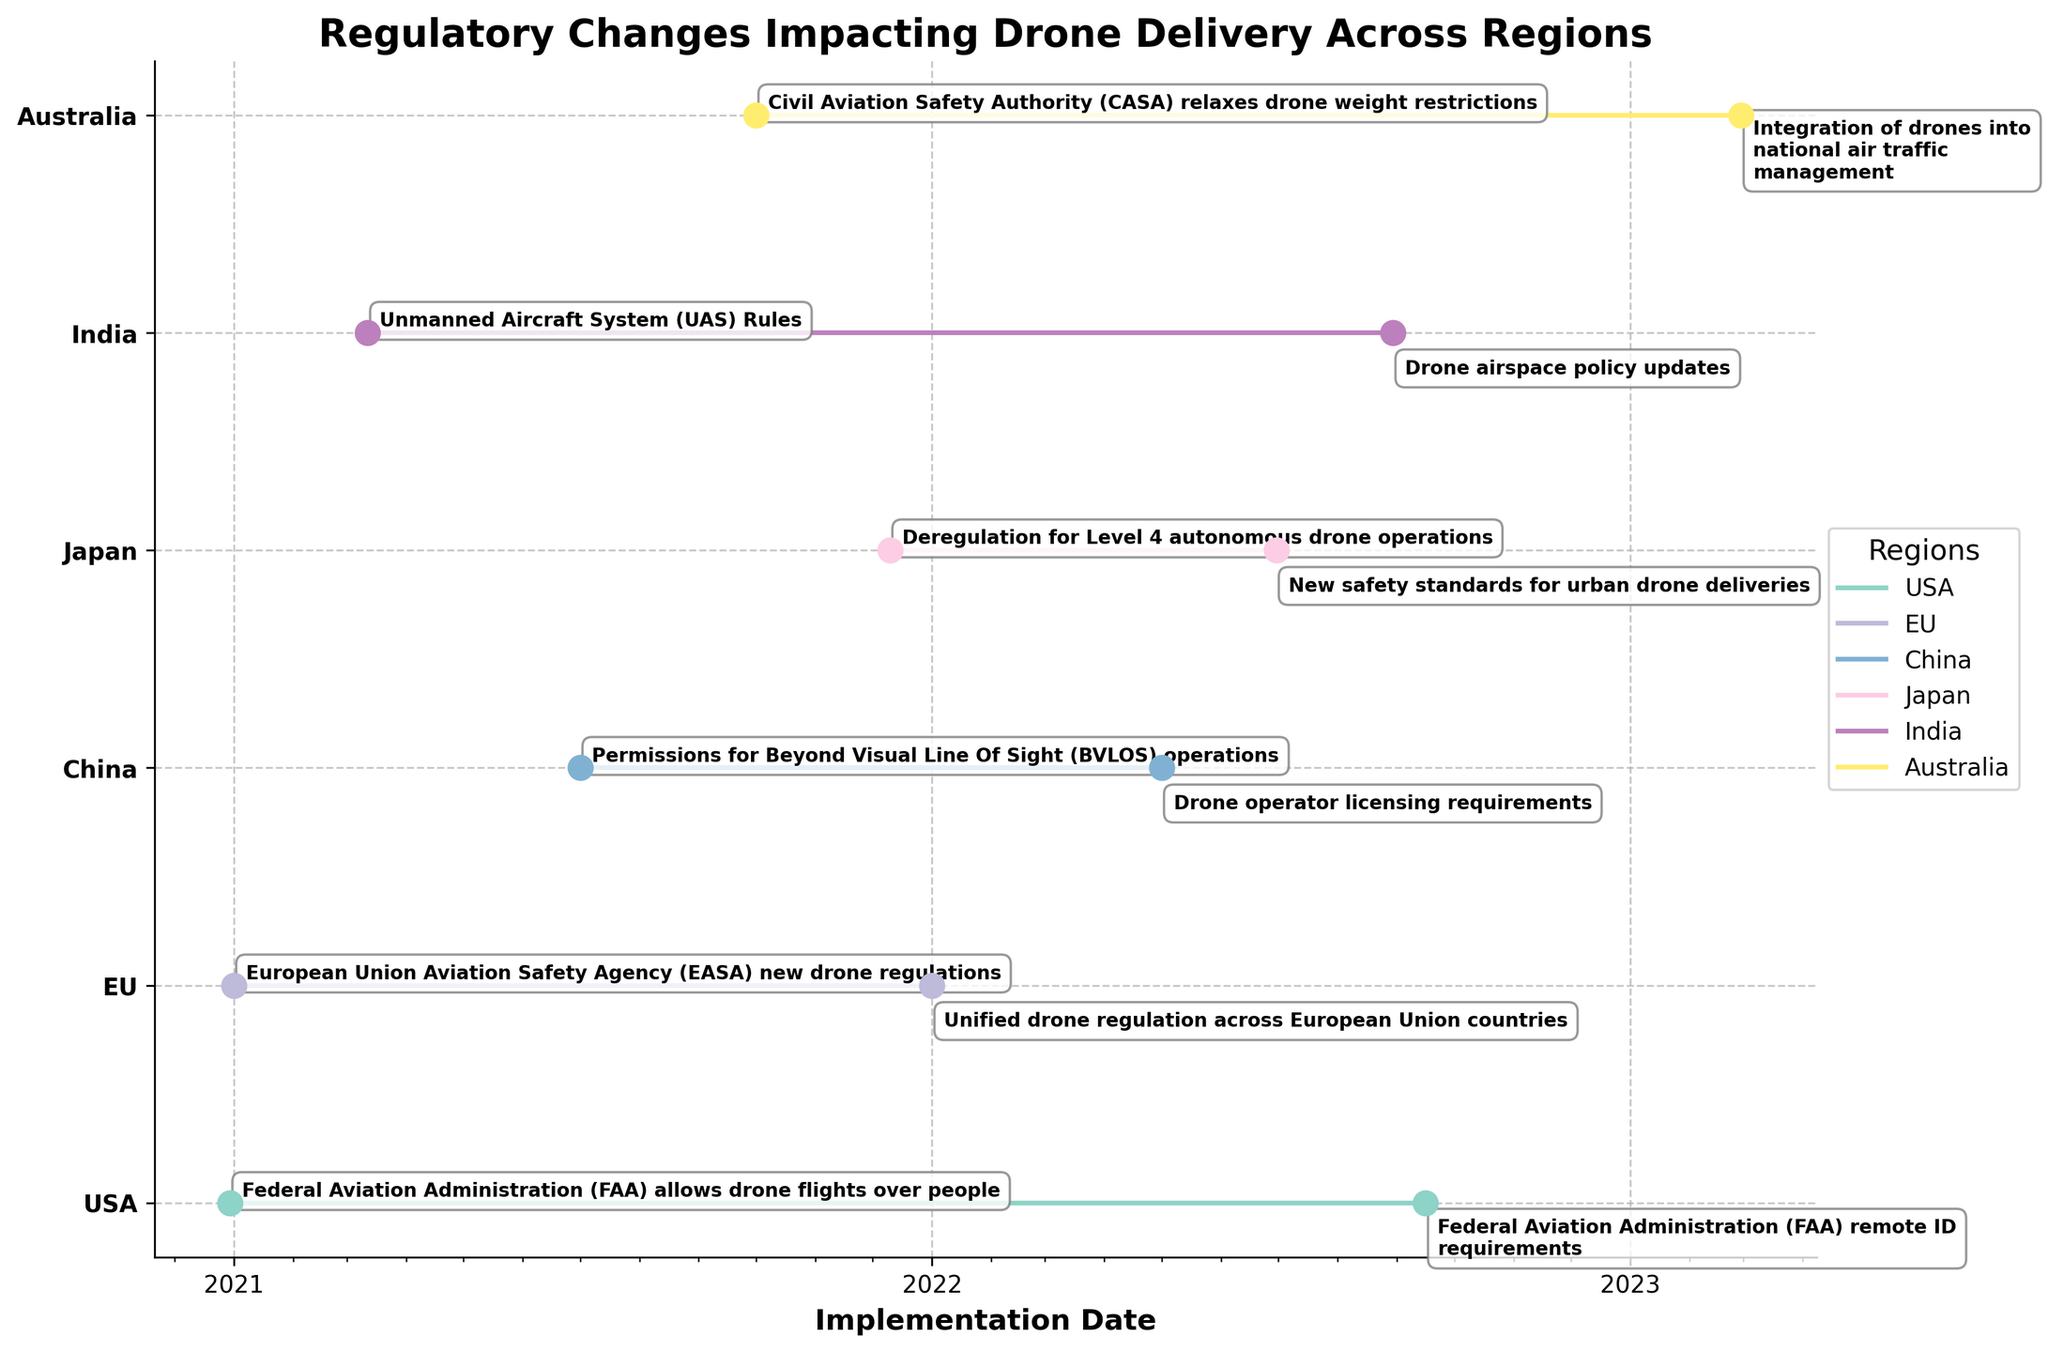What regions are shown in the figure? The figure uses different colors for distinct regions displayed on the vertical axis, which include USA, EU, China, Japan, India, and Australia.
Answer: USA, EU, China, Japan, India, Australia What is the latest regulatory change shown for Australia and when was it implemented? The timeline for Australia's regulatory changes is shown using the stair plot. The latest one is the "Integration of drones into national air traffic management," which was implemented on February 28, 2023.
Answer: February 28, 2023 Which region had the earliest regulatory change, and what was it? By looking at the start points of each stair step on the plot, we can see that the earliest change occurred in the EU with "European Union Aviation Safety Agency (EASA) new drone regulations" implemented on January 1, 2021.
Answer: EU, European Union Aviation Safety Agency (EASA) new drone regulations Compare the number of regulatory changes in the USA and China. Which region has more changes? By counting the number of stair steps or data points in each region's line, we observe that the USA has 2 regulatory changes, while China also has 2. Therefore, the number of regulatory changes is the same for both regions.
Answer: The same How long is the gap between the two regulatory changes for the USA? The first change in the USA was on December 30, 2020, and the second change was on September 16, 2022. To calculate the gap, subtract December 30, 2020, from September 16, 2022. The gap is approximately 1 year and 9 months.
Answer: Approximately 1 year and 9 months Which region implemented a regulatory change related to BVLOS operations and when? By looking at the annotations next to the stair steps in the figure, China has a regulatory change related to "Permissions for Beyond Visual Line Of Sight (BVLOS) operations," which was implemented on July 1, 2021.
Answer: China, July 1, 2021 How many regulatory changes were implemented globally in the year 2022? By counting the number of data points labeled with the year 2022 across all regions in the plot, we see there are 6 such changes: USA (one), EU (one), China (one), Japan (one), India (one), and Australia (one).
Answer: 6 What are the common types of regulatory changes in the data presented? By examining the annotations in the figure, common types of regulatory changes include new safety standards, airspace policy updates, licensing requirements, and permissions for BVLOS operations.
Answer: Safety standards, airspace policy updates, licensing requirements, BVLOS operations 